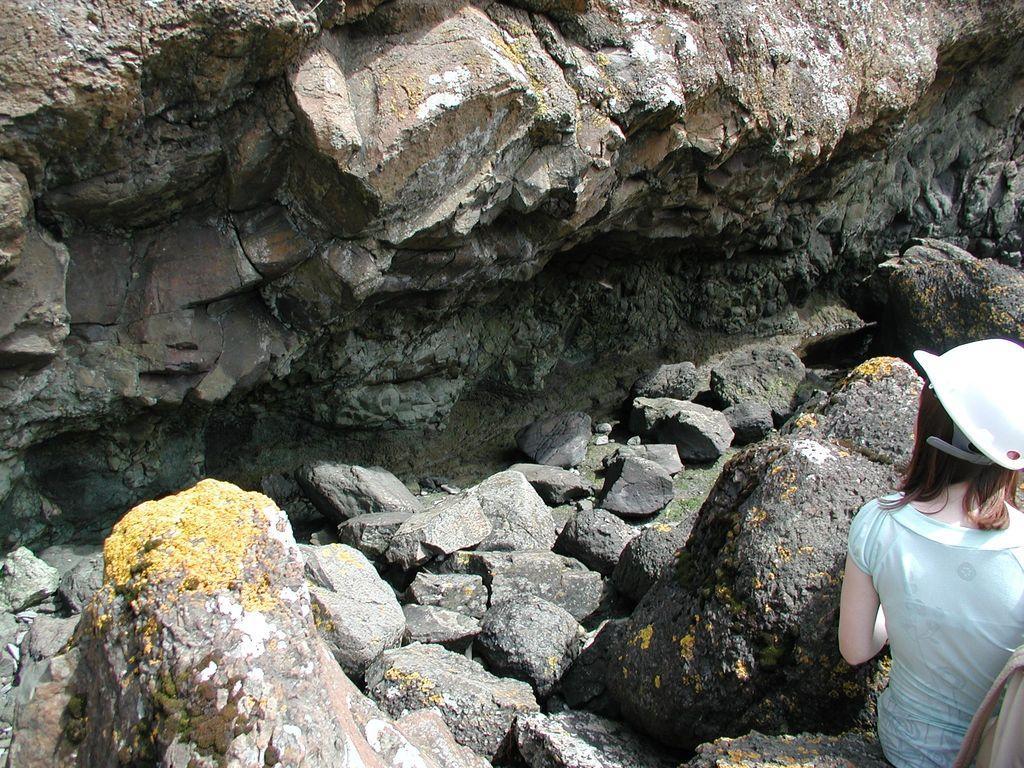Could you give a brief overview of what you see in this image? In the bottom right corner of the image a person is standing. In front of her there are some stones and hill. 